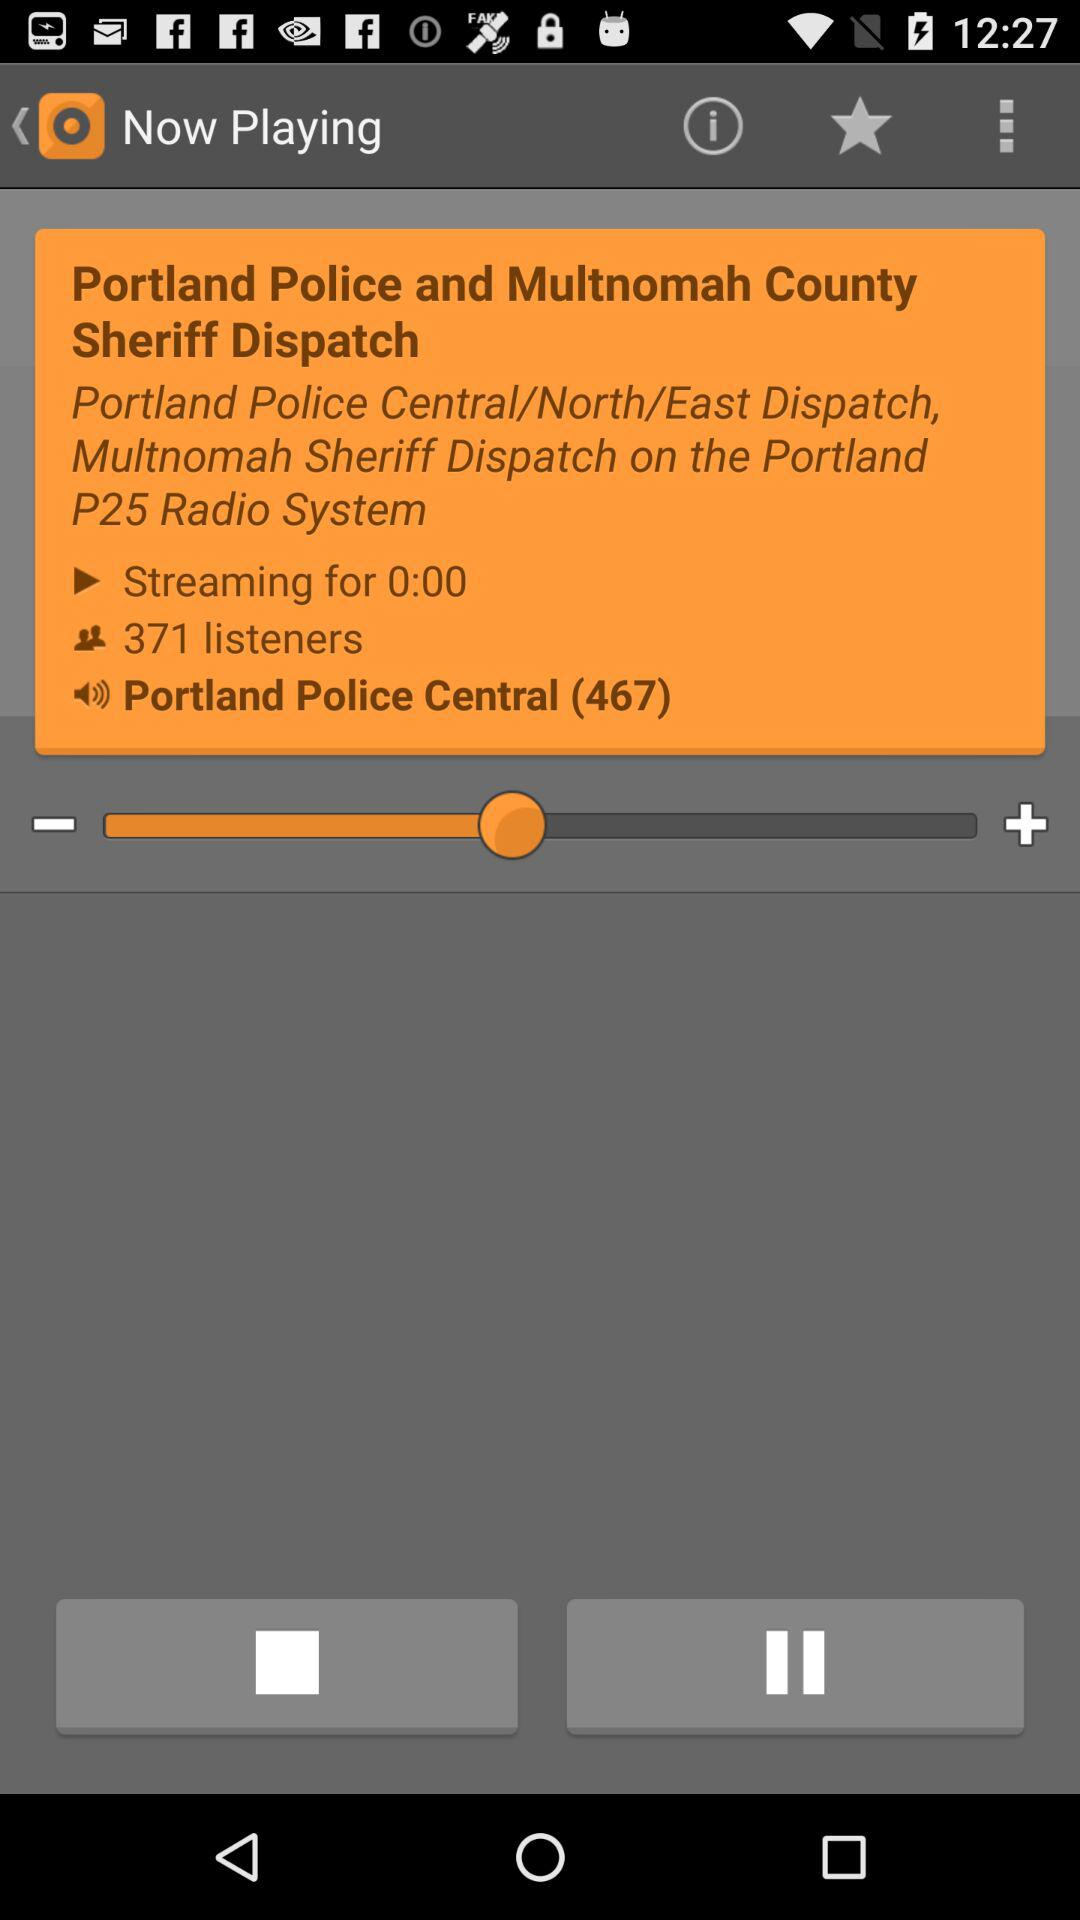How many listeners are listening? There are 371 people listening. 